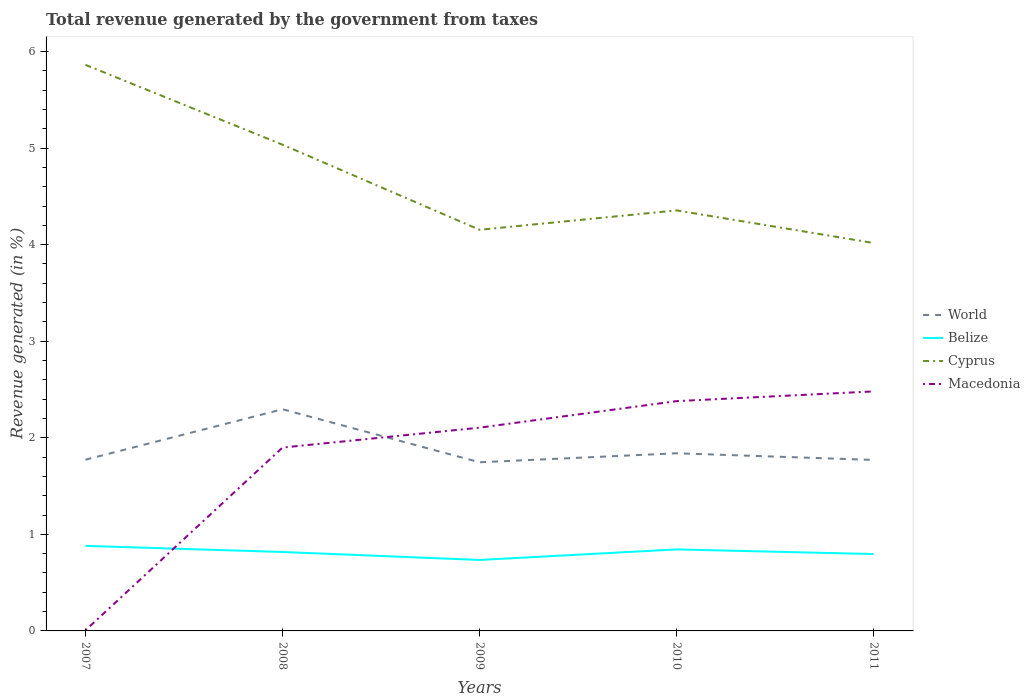How many different coloured lines are there?
Offer a very short reply. 4. Across all years, what is the maximum total revenue generated in World?
Your answer should be compact. 1.75. What is the total total revenue generated in Belize in the graph?
Offer a terse response. 0.02. What is the difference between the highest and the second highest total revenue generated in Macedonia?
Your answer should be very brief. 2.47. How many lines are there?
Provide a short and direct response. 4. How many years are there in the graph?
Your response must be concise. 5. What is the difference between two consecutive major ticks on the Y-axis?
Ensure brevity in your answer.  1. Does the graph contain grids?
Offer a terse response. No. Where does the legend appear in the graph?
Your response must be concise. Center right. How are the legend labels stacked?
Provide a short and direct response. Vertical. What is the title of the graph?
Your answer should be compact. Total revenue generated by the government from taxes. Does "Sweden" appear as one of the legend labels in the graph?
Give a very brief answer. No. What is the label or title of the X-axis?
Your answer should be very brief. Years. What is the label or title of the Y-axis?
Offer a very short reply. Revenue generated (in %). What is the Revenue generated (in %) in World in 2007?
Give a very brief answer. 1.77. What is the Revenue generated (in %) in Belize in 2007?
Give a very brief answer. 0.88. What is the Revenue generated (in %) of Cyprus in 2007?
Keep it short and to the point. 5.86. What is the Revenue generated (in %) in Macedonia in 2007?
Keep it short and to the point. 0.01. What is the Revenue generated (in %) in World in 2008?
Ensure brevity in your answer.  2.3. What is the Revenue generated (in %) in Belize in 2008?
Ensure brevity in your answer.  0.82. What is the Revenue generated (in %) in Cyprus in 2008?
Your answer should be compact. 5.04. What is the Revenue generated (in %) in Macedonia in 2008?
Provide a succinct answer. 1.9. What is the Revenue generated (in %) of World in 2009?
Offer a very short reply. 1.75. What is the Revenue generated (in %) in Belize in 2009?
Your answer should be compact. 0.73. What is the Revenue generated (in %) of Cyprus in 2009?
Offer a terse response. 4.15. What is the Revenue generated (in %) in Macedonia in 2009?
Make the answer very short. 2.1. What is the Revenue generated (in %) of World in 2010?
Your response must be concise. 1.84. What is the Revenue generated (in %) in Belize in 2010?
Give a very brief answer. 0.84. What is the Revenue generated (in %) of Cyprus in 2010?
Provide a succinct answer. 4.35. What is the Revenue generated (in %) in Macedonia in 2010?
Provide a succinct answer. 2.38. What is the Revenue generated (in %) of World in 2011?
Ensure brevity in your answer.  1.77. What is the Revenue generated (in %) of Belize in 2011?
Give a very brief answer. 0.8. What is the Revenue generated (in %) in Cyprus in 2011?
Your response must be concise. 4.02. What is the Revenue generated (in %) of Macedonia in 2011?
Your answer should be very brief. 2.48. Across all years, what is the maximum Revenue generated (in %) of World?
Your answer should be very brief. 2.3. Across all years, what is the maximum Revenue generated (in %) in Belize?
Your answer should be compact. 0.88. Across all years, what is the maximum Revenue generated (in %) of Cyprus?
Ensure brevity in your answer.  5.86. Across all years, what is the maximum Revenue generated (in %) of Macedonia?
Offer a very short reply. 2.48. Across all years, what is the minimum Revenue generated (in %) in World?
Make the answer very short. 1.75. Across all years, what is the minimum Revenue generated (in %) in Belize?
Provide a succinct answer. 0.73. Across all years, what is the minimum Revenue generated (in %) in Cyprus?
Your answer should be very brief. 4.02. Across all years, what is the minimum Revenue generated (in %) in Macedonia?
Give a very brief answer. 0.01. What is the total Revenue generated (in %) in World in the graph?
Give a very brief answer. 9.42. What is the total Revenue generated (in %) in Belize in the graph?
Make the answer very short. 4.07. What is the total Revenue generated (in %) of Cyprus in the graph?
Keep it short and to the point. 23.42. What is the total Revenue generated (in %) in Macedonia in the graph?
Keep it short and to the point. 8.87. What is the difference between the Revenue generated (in %) in World in 2007 and that in 2008?
Your answer should be very brief. -0.52. What is the difference between the Revenue generated (in %) of Belize in 2007 and that in 2008?
Provide a short and direct response. 0.06. What is the difference between the Revenue generated (in %) in Cyprus in 2007 and that in 2008?
Your answer should be very brief. 0.83. What is the difference between the Revenue generated (in %) of Macedonia in 2007 and that in 2008?
Ensure brevity in your answer.  -1.89. What is the difference between the Revenue generated (in %) of World in 2007 and that in 2009?
Provide a short and direct response. 0.03. What is the difference between the Revenue generated (in %) in Belize in 2007 and that in 2009?
Offer a very short reply. 0.15. What is the difference between the Revenue generated (in %) of Cyprus in 2007 and that in 2009?
Keep it short and to the point. 1.71. What is the difference between the Revenue generated (in %) of Macedonia in 2007 and that in 2009?
Give a very brief answer. -2.1. What is the difference between the Revenue generated (in %) of World in 2007 and that in 2010?
Your response must be concise. -0.07. What is the difference between the Revenue generated (in %) of Belize in 2007 and that in 2010?
Provide a short and direct response. 0.04. What is the difference between the Revenue generated (in %) in Cyprus in 2007 and that in 2010?
Provide a short and direct response. 1.51. What is the difference between the Revenue generated (in %) in Macedonia in 2007 and that in 2010?
Your answer should be very brief. -2.37. What is the difference between the Revenue generated (in %) in World in 2007 and that in 2011?
Give a very brief answer. 0. What is the difference between the Revenue generated (in %) in Belize in 2007 and that in 2011?
Your answer should be compact. 0.08. What is the difference between the Revenue generated (in %) in Cyprus in 2007 and that in 2011?
Make the answer very short. 1.84. What is the difference between the Revenue generated (in %) in Macedonia in 2007 and that in 2011?
Offer a terse response. -2.47. What is the difference between the Revenue generated (in %) in World in 2008 and that in 2009?
Your response must be concise. 0.55. What is the difference between the Revenue generated (in %) in Belize in 2008 and that in 2009?
Provide a succinct answer. 0.08. What is the difference between the Revenue generated (in %) of Cyprus in 2008 and that in 2009?
Your response must be concise. 0.88. What is the difference between the Revenue generated (in %) of Macedonia in 2008 and that in 2009?
Your answer should be compact. -0.21. What is the difference between the Revenue generated (in %) of World in 2008 and that in 2010?
Provide a succinct answer. 0.46. What is the difference between the Revenue generated (in %) in Belize in 2008 and that in 2010?
Offer a terse response. -0.03. What is the difference between the Revenue generated (in %) of Cyprus in 2008 and that in 2010?
Give a very brief answer. 0.68. What is the difference between the Revenue generated (in %) of Macedonia in 2008 and that in 2010?
Offer a terse response. -0.48. What is the difference between the Revenue generated (in %) of World in 2008 and that in 2011?
Your answer should be very brief. 0.52. What is the difference between the Revenue generated (in %) in Belize in 2008 and that in 2011?
Offer a very short reply. 0.02. What is the difference between the Revenue generated (in %) of Cyprus in 2008 and that in 2011?
Provide a succinct answer. 1.02. What is the difference between the Revenue generated (in %) of Macedonia in 2008 and that in 2011?
Offer a very short reply. -0.58. What is the difference between the Revenue generated (in %) of World in 2009 and that in 2010?
Offer a terse response. -0.09. What is the difference between the Revenue generated (in %) in Belize in 2009 and that in 2010?
Provide a short and direct response. -0.11. What is the difference between the Revenue generated (in %) in Cyprus in 2009 and that in 2010?
Give a very brief answer. -0.2. What is the difference between the Revenue generated (in %) of Macedonia in 2009 and that in 2010?
Offer a terse response. -0.27. What is the difference between the Revenue generated (in %) in World in 2009 and that in 2011?
Make the answer very short. -0.02. What is the difference between the Revenue generated (in %) of Belize in 2009 and that in 2011?
Give a very brief answer. -0.06. What is the difference between the Revenue generated (in %) in Cyprus in 2009 and that in 2011?
Offer a very short reply. 0.14. What is the difference between the Revenue generated (in %) in Macedonia in 2009 and that in 2011?
Keep it short and to the point. -0.38. What is the difference between the Revenue generated (in %) in World in 2010 and that in 2011?
Your response must be concise. 0.07. What is the difference between the Revenue generated (in %) of Belize in 2010 and that in 2011?
Ensure brevity in your answer.  0.05. What is the difference between the Revenue generated (in %) of Cyprus in 2010 and that in 2011?
Your response must be concise. 0.34. What is the difference between the Revenue generated (in %) of Macedonia in 2010 and that in 2011?
Your response must be concise. -0.1. What is the difference between the Revenue generated (in %) of World in 2007 and the Revenue generated (in %) of Belize in 2008?
Offer a very short reply. 0.96. What is the difference between the Revenue generated (in %) in World in 2007 and the Revenue generated (in %) in Cyprus in 2008?
Provide a succinct answer. -3.26. What is the difference between the Revenue generated (in %) in World in 2007 and the Revenue generated (in %) in Macedonia in 2008?
Your response must be concise. -0.13. What is the difference between the Revenue generated (in %) in Belize in 2007 and the Revenue generated (in %) in Cyprus in 2008?
Offer a terse response. -4.15. What is the difference between the Revenue generated (in %) of Belize in 2007 and the Revenue generated (in %) of Macedonia in 2008?
Keep it short and to the point. -1.02. What is the difference between the Revenue generated (in %) in Cyprus in 2007 and the Revenue generated (in %) in Macedonia in 2008?
Ensure brevity in your answer.  3.96. What is the difference between the Revenue generated (in %) of World in 2007 and the Revenue generated (in %) of Belize in 2009?
Make the answer very short. 1.04. What is the difference between the Revenue generated (in %) of World in 2007 and the Revenue generated (in %) of Cyprus in 2009?
Provide a short and direct response. -2.38. What is the difference between the Revenue generated (in %) of World in 2007 and the Revenue generated (in %) of Macedonia in 2009?
Offer a very short reply. -0.33. What is the difference between the Revenue generated (in %) of Belize in 2007 and the Revenue generated (in %) of Cyprus in 2009?
Your response must be concise. -3.27. What is the difference between the Revenue generated (in %) of Belize in 2007 and the Revenue generated (in %) of Macedonia in 2009?
Keep it short and to the point. -1.22. What is the difference between the Revenue generated (in %) in Cyprus in 2007 and the Revenue generated (in %) in Macedonia in 2009?
Make the answer very short. 3.76. What is the difference between the Revenue generated (in %) in World in 2007 and the Revenue generated (in %) in Belize in 2010?
Give a very brief answer. 0.93. What is the difference between the Revenue generated (in %) in World in 2007 and the Revenue generated (in %) in Cyprus in 2010?
Offer a very short reply. -2.58. What is the difference between the Revenue generated (in %) of World in 2007 and the Revenue generated (in %) of Macedonia in 2010?
Ensure brevity in your answer.  -0.61. What is the difference between the Revenue generated (in %) of Belize in 2007 and the Revenue generated (in %) of Cyprus in 2010?
Your answer should be very brief. -3.47. What is the difference between the Revenue generated (in %) of Belize in 2007 and the Revenue generated (in %) of Macedonia in 2010?
Give a very brief answer. -1.5. What is the difference between the Revenue generated (in %) in Cyprus in 2007 and the Revenue generated (in %) in Macedonia in 2010?
Offer a terse response. 3.48. What is the difference between the Revenue generated (in %) of World in 2007 and the Revenue generated (in %) of Belize in 2011?
Provide a succinct answer. 0.98. What is the difference between the Revenue generated (in %) in World in 2007 and the Revenue generated (in %) in Cyprus in 2011?
Give a very brief answer. -2.24. What is the difference between the Revenue generated (in %) in World in 2007 and the Revenue generated (in %) in Macedonia in 2011?
Offer a very short reply. -0.71. What is the difference between the Revenue generated (in %) in Belize in 2007 and the Revenue generated (in %) in Cyprus in 2011?
Provide a short and direct response. -3.14. What is the difference between the Revenue generated (in %) of Belize in 2007 and the Revenue generated (in %) of Macedonia in 2011?
Keep it short and to the point. -1.6. What is the difference between the Revenue generated (in %) in Cyprus in 2007 and the Revenue generated (in %) in Macedonia in 2011?
Offer a terse response. 3.38. What is the difference between the Revenue generated (in %) in World in 2008 and the Revenue generated (in %) in Belize in 2009?
Give a very brief answer. 1.56. What is the difference between the Revenue generated (in %) in World in 2008 and the Revenue generated (in %) in Cyprus in 2009?
Offer a very short reply. -1.86. What is the difference between the Revenue generated (in %) in World in 2008 and the Revenue generated (in %) in Macedonia in 2009?
Your answer should be very brief. 0.19. What is the difference between the Revenue generated (in %) in Belize in 2008 and the Revenue generated (in %) in Cyprus in 2009?
Keep it short and to the point. -3.34. What is the difference between the Revenue generated (in %) of Belize in 2008 and the Revenue generated (in %) of Macedonia in 2009?
Provide a succinct answer. -1.29. What is the difference between the Revenue generated (in %) in Cyprus in 2008 and the Revenue generated (in %) in Macedonia in 2009?
Your response must be concise. 2.93. What is the difference between the Revenue generated (in %) in World in 2008 and the Revenue generated (in %) in Belize in 2010?
Make the answer very short. 1.45. What is the difference between the Revenue generated (in %) of World in 2008 and the Revenue generated (in %) of Cyprus in 2010?
Keep it short and to the point. -2.06. What is the difference between the Revenue generated (in %) in World in 2008 and the Revenue generated (in %) in Macedonia in 2010?
Offer a terse response. -0.08. What is the difference between the Revenue generated (in %) of Belize in 2008 and the Revenue generated (in %) of Cyprus in 2010?
Give a very brief answer. -3.54. What is the difference between the Revenue generated (in %) of Belize in 2008 and the Revenue generated (in %) of Macedonia in 2010?
Your response must be concise. -1.56. What is the difference between the Revenue generated (in %) of Cyprus in 2008 and the Revenue generated (in %) of Macedonia in 2010?
Give a very brief answer. 2.66. What is the difference between the Revenue generated (in %) in World in 2008 and the Revenue generated (in %) in Belize in 2011?
Make the answer very short. 1.5. What is the difference between the Revenue generated (in %) in World in 2008 and the Revenue generated (in %) in Cyprus in 2011?
Offer a very short reply. -1.72. What is the difference between the Revenue generated (in %) in World in 2008 and the Revenue generated (in %) in Macedonia in 2011?
Keep it short and to the point. -0.18. What is the difference between the Revenue generated (in %) in Belize in 2008 and the Revenue generated (in %) in Cyprus in 2011?
Keep it short and to the point. -3.2. What is the difference between the Revenue generated (in %) of Belize in 2008 and the Revenue generated (in %) of Macedonia in 2011?
Provide a short and direct response. -1.66. What is the difference between the Revenue generated (in %) of Cyprus in 2008 and the Revenue generated (in %) of Macedonia in 2011?
Offer a very short reply. 2.55. What is the difference between the Revenue generated (in %) of World in 2009 and the Revenue generated (in %) of Belize in 2010?
Offer a very short reply. 0.9. What is the difference between the Revenue generated (in %) in World in 2009 and the Revenue generated (in %) in Cyprus in 2010?
Provide a succinct answer. -2.61. What is the difference between the Revenue generated (in %) of World in 2009 and the Revenue generated (in %) of Macedonia in 2010?
Provide a short and direct response. -0.63. What is the difference between the Revenue generated (in %) of Belize in 2009 and the Revenue generated (in %) of Cyprus in 2010?
Keep it short and to the point. -3.62. What is the difference between the Revenue generated (in %) of Belize in 2009 and the Revenue generated (in %) of Macedonia in 2010?
Offer a terse response. -1.64. What is the difference between the Revenue generated (in %) of Cyprus in 2009 and the Revenue generated (in %) of Macedonia in 2010?
Your response must be concise. 1.77. What is the difference between the Revenue generated (in %) in World in 2009 and the Revenue generated (in %) in Belize in 2011?
Make the answer very short. 0.95. What is the difference between the Revenue generated (in %) of World in 2009 and the Revenue generated (in %) of Cyprus in 2011?
Offer a very short reply. -2.27. What is the difference between the Revenue generated (in %) in World in 2009 and the Revenue generated (in %) in Macedonia in 2011?
Your answer should be compact. -0.73. What is the difference between the Revenue generated (in %) in Belize in 2009 and the Revenue generated (in %) in Cyprus in 2011?
Your answer should be very brief. -3.28. What is the difference between the Revenue generated (in %) in Belize in 2009 and the Revenue generated (in %) in Macedonia in 2011?
Offer a very short reply. -1.75. What is the difference between the Revenue generated (in %) of Cyprus in 2009 and the Revenue generated (in %) of Macedonia in 2011?
Your answer should be compact. 1.67. What is the difference between the Revenue generated (in %) of World in 2010 and the Revenue generated (in %) of Belize in 2011?
Keep it short and to the point. 1.04. What is the difference between the Revenue generated (in %) of World in 2010 and the Revenue generated (in %) of Cyprus in 2011?
Ensure brevity in your answer.  -2.18. What is the difference between the Revenue generated (in %) of World in 2010 and the Revenue generated (in %) of Macedonia in 2011?
Ensure brevity in your answer.  -0.64. What is the difference between the Revenue generated (in %) in Belize in 2010 and the Revenue generated (in %) in Cyprus in 2011?
Make the answer very short. -3.17. What is the difference between the Revenue generated (in %) in Belize in 2010 and the Revenue generated (in %) in Macedonia in 2011?
Ensure brevity in your answer.  -1.64. What is the difference between the Revenue generated (in %) in Cyprus in 2010 and the Revenue generated (in %) in Macedonia in 2011?
Offer a terse response. 1.87. What is the average Revenue generated (in %) in World per year?
Your answer should be compact. 1.89. What is the average Revenue generated (in %) in Belize per year?
Provide a succinct answer. 0.81. What is the average Revenue generated (in %) in Cyprus per year?
Offer a very short reply. 4.68. What is the average Revenue generated (in %) of Macedonia per year?
Ensure brevity in your answer.  1.77. In the year 2007, what is the difference between the Revenue generated (in %) in World and Revenue generated (in %) in Belize?
Your answer should be very brief. 0.89. In the year 2007, what is the difference between the Revenue generated (in %) of World and Revenue generated (in %) of Cyprus?
Give a very brief answer. -4.09. In the year 2007, what is the difference between the Revenue generated (in %) in World and Revenue generated (in %) in Macedonia?
Offer a very short reply. 1.77. In the year 2007, what is the difference between the Revenue generated (in %) of Belize and Revenue generated (in %) of Cyprus?
Ensure brevity in your answer.  -4.98. In the year 2007, what is the difference between the Revenue generated (in %) in Belize and Revenue generated (in %) in Macedonia?
Offer a very short reply. 0.87. In the year 2007, what is the difference between the Revenue generated (in %) in Cyprus and Revenue generated (in %) in Macedonia?
Give a very brief answer. 5.86. In the year 2008, what is the difference between the Revenue generated (in %) in World and Revenue generated (in %) in Belize?
Your answer should be compact. 1.48. In the year 2008, what is the difference between the Revenue generated (in %) in World and Revenue generated (in %) in Cyprus?
Offer a very short reply. -2.74. In the year 2008, what is the difference between the Revenue generated (in %) of World and Revenue generated (in %) of Macedonia?
Your answer should be compact. 0.4. In the year 2008, what is the difference between the Revenue generated (in %) of Belize and Revenue generated (in %) of Cyprus?
Keep it short and to the point. -4.22. In the year 2008, what is the difference between the Revenue generated (in %) of Belize and Revenue generated (in %) of Macedonia?
Your answer should be very brief. -1.08. In the year 2008, what is the difference between the Revenue generated (in %) in Cyprus and Revenue generated (in %) in Macedonia?
Make the answer very short. 3.14. In the year 2009, what is the difference between the Revenue generated (in %) of World and Revenue generated (in %) of Belize?
Make the answer very short. 1.01. In the year 2009, what is the difference between the Revenue generated (in %) in World and Revenue generated (in %) in Cyprus?
Keep it short and to the point. -2.41. In the year 2009, what is the difference between the Revenue generated (in %) of World and Revenue generated (in %) of Macedonia?
Offer a very short reply. -0.36. In the year 2009, what is the difference between the Revenue generated (in %) of Belize and Revenue generated (in %) of Cyprus?
Offer a terse response. -3.42. In the year 2009, what is the difference between the Revenue generated (in %) in Belize and Revenue generated (in %) in Macedonia?
Your answer should be very brief. -1.37. In the year 2009, what is the difference between the Revenue generated (in %) of Cyprus and Revenue generated (in %) of Macedonia?
Provide a succinct answer. 2.05. In the year 2010, what is the difference between the Revenue generated (in %) in World and Revenue generated (in %) in Belize?
Provide a succinct answer. 1. In the year 2010, what is the difference between the Revenue generated (in %) in World and Revenue generated (in %) in Cyprus?
Offer a very short reply. -2.52. In the year 2010, what is the difference between the Revenue generated (in %) of World and Revenue generated (in %) of Macedonia?
Offer a terse response. -0.54. In the year 2010, what is the difference between the Revenue generated (in %) of Belize and Revenue generated (in %) of Cyprus?
Make the answer very short. -3.51. In the year 2010, what is the difference between the Revenue generated (in %) of Belize and Revenue generated (in %) of Macedonia?
Ensure brevity in your answer.  -1.54. In the year 2010, what is the difference between the Revenue generated (in %) of Cyprus and Revenue generated (in %) of Macedonia?
Provide a short and direct response. 1.98. In the year 2011, what is the difference between the Revenue generated (in %) of World and Revenue generated (in %) of Belize?
Your answer should be compact. 0.97. In the year 2011, what is the difference between the Revenue generated (in %) in World and Revenue generated (in %) in Cyprus?
Provide a succinct answer. -2.25. In the year 2011, what is the difference between the Revenue generated (in %) of World and Revenue generated (in %) of Macedonia?
Make the answer very short. -0.71. In the year 2011, what is the difference between the Revenue generated (in %) of Belize and Revenue generated (in %) of Cyprus?
Ensure brevity in your answer.  -3.22. In the year 2011, what is the difference between the Revenue generated (in %) of Belize and Revenue generated (in %) of Macedonia?
Your response must be concise. -1.68. In the year 2011, what is the difference between the Revenue generated (in %) of Cyprus and Revenue generated (in %) of Macedonia?
Your answer should be very brief. 1.54. What is the ratio of the Revenue generated (in %) of World in 2007 to that in 2008?
Offer a terse response. 0.77. What is the ratio of the Revenue generated (in %) in Belize in 2007 to that in 2008?
Offer a terse response. 1.08. What is the ratio of the Revenue generated (in %) in Cyprus in 2007 to that in 2008?
Give a very brief answer. 1.16. What is the ratio of the Revenue generated (in %) in Macedonia in 2007 to that in 2008?
Keep it short and to the point. 0. What is the ratio of the Revenue generated (in %) in World in 2007 to that in 2009?
Make the answer very short. 1.02. What is the ratio of the Revenue generated (in %) in Belize in 2007 to that in 2009?
Offer a terse response. 1.2. What is the ratio of the Revenue generated (in %) of Cyprus in 2007 to that in 2009?
Make the answer very short. 1.41. What is the ratio of the Revenue generated (in %) of Macedonia in 2007 to that in 2009?
Your answer should be very brief. 0. What is the ratio of the Revenue generated (in %) in World in 2007 to that in 2010?
Offer a terse response. 0.96. What is the ratio of the Revenue generated (in %) of Belize in 2007 to that in 2010?
Offer a very short reply. 1.04. What is the ratio of the Revenue generated (in %) of Cyprus in 2007 to that in 2010?
Provide a short and direct response. 1.35. What is the ratio of the Revenue generated (in %) in Macedonia in 2007 to that in 2010?
Offer a terse response. 0. What is the ratio of the Revenue generated (in %) of World in 2007 to that in 2011?
Your answer should be compact. 1. What is the ratio of the Revenue generated (in %) in Belize in 2007 to that in 2011?
Provide a succinct answer. 1.11. What is the ratio of the Revenue generated (in %) of Cyprus in 2007 to that in 2011?
Your answer should be very brief. 1.46. What is the ratio of the Revenue generated (in %) in Macedonia in 2007 to that in 2011?
Ensure brevity in your answer.  0. What is the ratio of the Revenue generated (in %) in World in 2008 to that in 2009?
Your response must be concise. 1.31. What is the ratio of the Revenue generated (in %) of Belize in 2008 to that in 2009?
Provide a succinct answer. 1.11. What is the ratio of the Revenue generated (in %) in Cyprus in 2008 to that in 2009?
Provide a succinct answer. 1.21. What is the ratio of the Revenue generated (in %) in Macedonia in 2008 to that in 2009?
Your answer should be compact. 0.9. What is the ratio of the Revenue generated (in %) of World in 2008 to that in 2010?
Offer a terse response. 1.25. What is the ratio of the Revenue generated (in %) of Belize in 2008 to that in 2010?
Keep it short and to the point. 0.97. What is the ratio of the Revenue generated (in %) of Cyprus in 2008 to that in 2010?
Keep it short and to the point. 1.16. What is the ratio of the Revenue generated (in %) of Macedonia in 2008 to that in 2010?
Offer a very short reply. 0.8. What is the ratio of the Revenue generated (in %) of World in 2008 to that in 2011?
Provide a succinct answer. 1.3. What is the ratio of the Revenue generated (in %) in Belize in 2008 to that in 2011?
Your answer should be very brief. 1.03. What is the ratio of the Revenue generated (in %) in Cyprus in 2008 to that in 2011?
Offer a terse response. 1.25. What is the ratio of the Revenue generated (in %) in Macedonia in 2008 to that in 2011?
Offer a very short reply. 0.77. What is the ratio of the Revenue generated (in %) in World in 2009 to that in 2010?
Provide a short and direct response. 0.95. What is the ratio of the Revenue generated (in %) of Belize in 2009 to that in 2010?
Make the answer very short. 0.87. What is the ratio of the Revenue generated (in %) of Cyprus in 2009 to that in 2010?
Your answer should be very brief. 0.95. What is the ratio of the Revenue generated (in %) of Macedonia in 2009 to that in 2010?
Offer a very short reply. 0.88. What is the ratio of the Revenue generated (in %) in World in 2009 to that in 2011?
Offer a very short reply. 0.99. What is the ratio of the Revenue generated (in %) in Cyprus in 2009 to that in 2011?
Your answer should be very brief. 1.03. What is the ratio of the Revenue generated (in %) of Macedonia in 2009 to that in 2011?
Ensure brevity in your answer.  0.85. What is the ratio of the Revenue generated (in %) in World in 2010 to that in 2011?
Provide a short and direct response. 1.04. What is the ratio of the Revenue generated (in %) in Belize in 2010 to that in 2011?
Give a very brief answer. 1.06. What is the ratio of the Revenue generated (in %) of Cyprus in 2010 to that in 2011?
Make the answer very short. 1.08. What is the ratio of the Revenue generated (in %) in Macedonia in 2010 to that in 2011?
Your response must be concise. 0.96. What is the difference between the highest and the second highest Revenue generated (in %) in World?
Your answer should be compact. 0.46. What is the difference between the highest and the second highest Revenue generated (in %) of Belize?
Make the answer very short. 0.04. What is the difference between the highest and the second highest Revenue generated (in %) of Cyprus?
Make the answer very short. 0.83. What is the difference between the highest and the second highest Revenue generated (in %) in Macedonia?
Offer a very short reply. 0.1. What is the difference between the highest and the lowest Revenue generated (in %) in World?
Offer a very short reply. 0.55. What is the difference between the highest and the lowest Revenue generated (in %) of Belize?
Ensure brevity in your answer.  0.15. What is the difference between the highest and the lowest Revenue generated (in %) in Cyprus?
Your answer should be compact. 1.84. What is the difference between the highest and the lowest Revenue generated (in %) in Macedonia?
Offer a terse response. 2.47. 